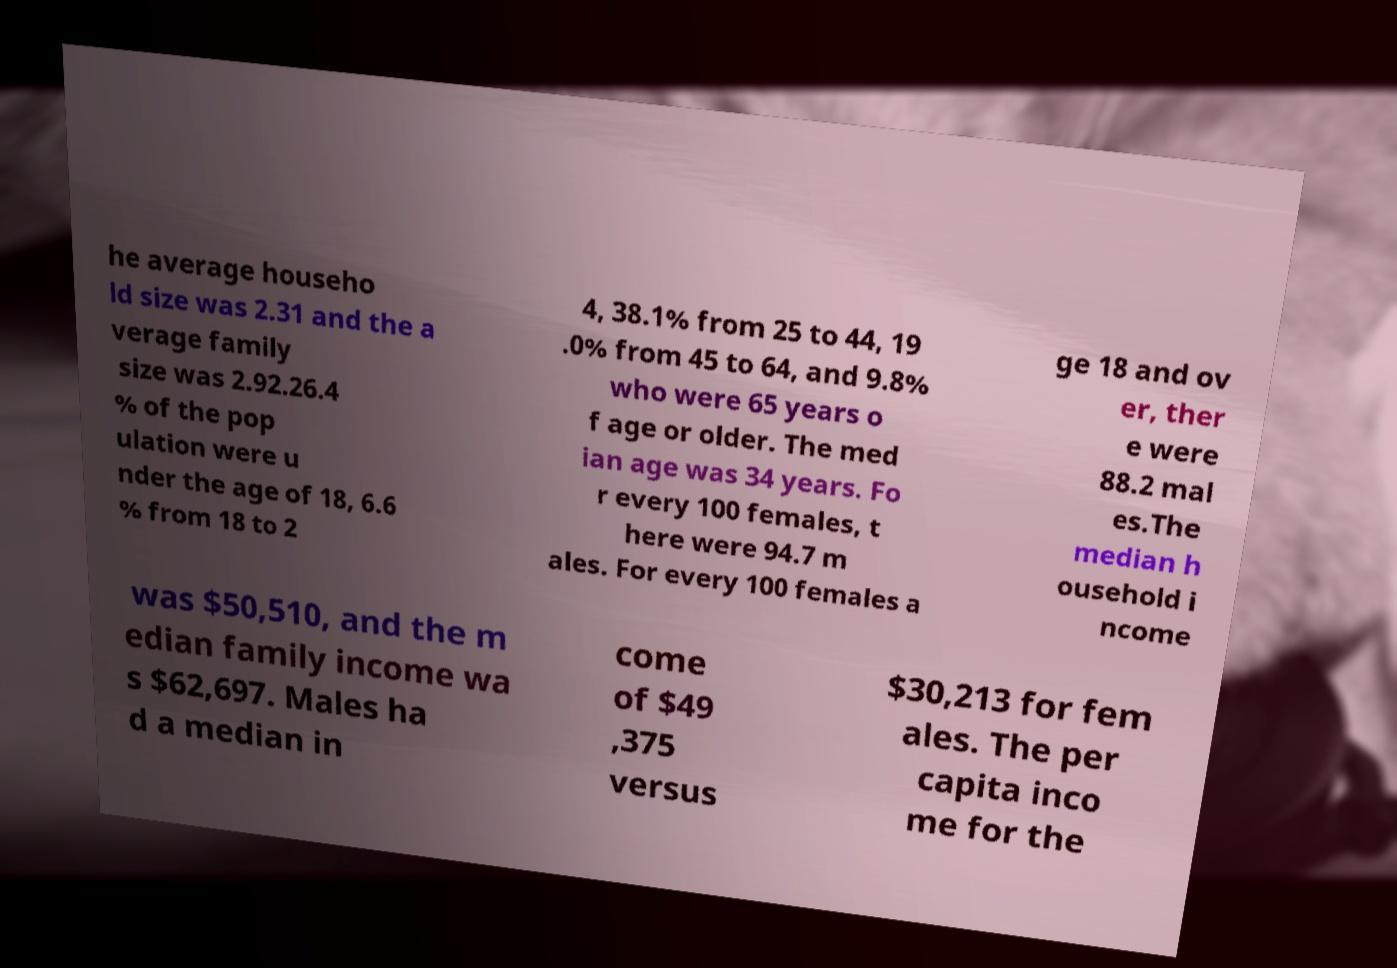Please identify and transcribe the text found in this image. he average househo ld size was 2.31 and the a verage family size was 2.92.26.4 % of the pop ulation were u nder the age of 18, 6.6 % from 18 to 2 4, 38.1% from 25 to 44, 19 .0% from 45 to 64, and 9.8% who were 65 years o f age or older. The med ian age was 34 years. Fo r every 100 females, t here were 94.7 m ales. For every 100 females a ge 18 and ov er, ther e were 88.2 mal es.The median h ousehold i ncome was $50,510, and the m edian family income wa s $62,697. Males ha d a median in come of $49 ,375 versus $30,213 for fem ales. The per capita inco me for the 